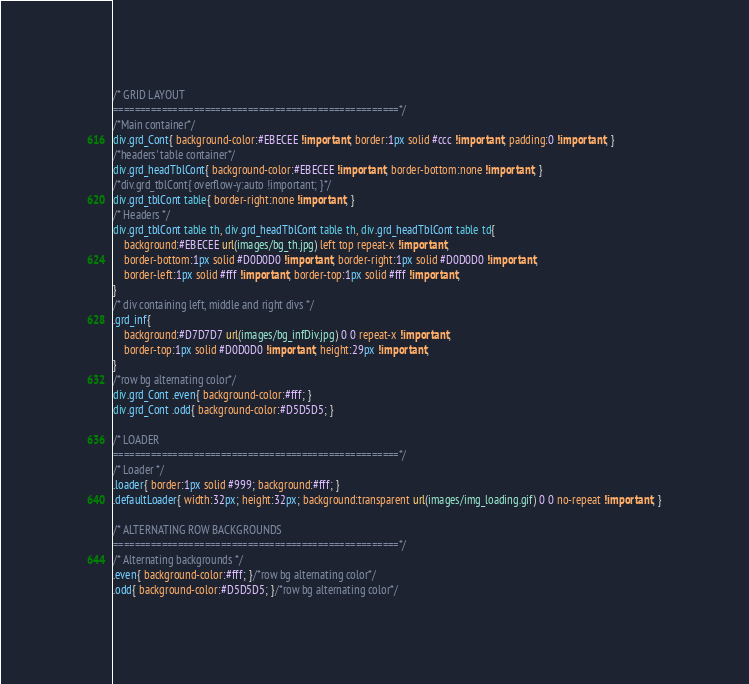Convert code to text. <code><loc_0><loc_0><loc_500><loc_500><_CSS_>/* GRID LAYOUT
=====================================================*/
/*Main container*/
div.grd_Cont{ background-color:#EBECEE !important; border:1px solid #ccc !important; padding:0 !important; }
/*headers' table container*/
div.grd_headTblCont{ background-color:#EBECEE !important; border-bottom:none !important; }
/*div.grd_tblCont{ overflow-y:auto !important; }*/
div.grd_tblCont table{ border-right:none !important; }
/* Headers */
div.grd_tblCont table th, div.grd_headTblCont table th, div.grd_headTblCont table td{
	background:#EBECEE url(images/bg_th.jpg) left top repeat-x !important;
	border-bottom:1px solid #D0D0D0 !important; border-right:1px solid #D0D0D0 !important;
	border-left:1px solid #fff !important; border-top:1px solid #fff !important;
}
/* div containing left, middle and right divs */
.grd_inf{ 
	background:#D7D7D7 url(images/bg_infDiv.jpg) 0 0 repeat-x !important; 
	border-top:1px solid #D0D0D0 !important; height:29px !important;
}
/*row bg alternating color*/
div.grd_Cont .even{ background-color:#fff; }
div.grd_Cont .odd{ background-color:#D5D5D5; }

/* LOADER
=====================================================*/
/* Loader */
.loader{ border:1px solid #999; background:#fff; }
.defaultLoader{ width:32px; height:32px; background:transparent url(images/img_loading.gif) 0 0 no-repeat !important; }

/* ALTERNATING ROW BACKGROUNDS
=====================================================*/
/* Alternating backgrounds */
.even{ background-color:#fff; }/*row bg alternating color*/
.odd{ background-color:#D5D5D5; }/*row bg alternating color*/</code> 